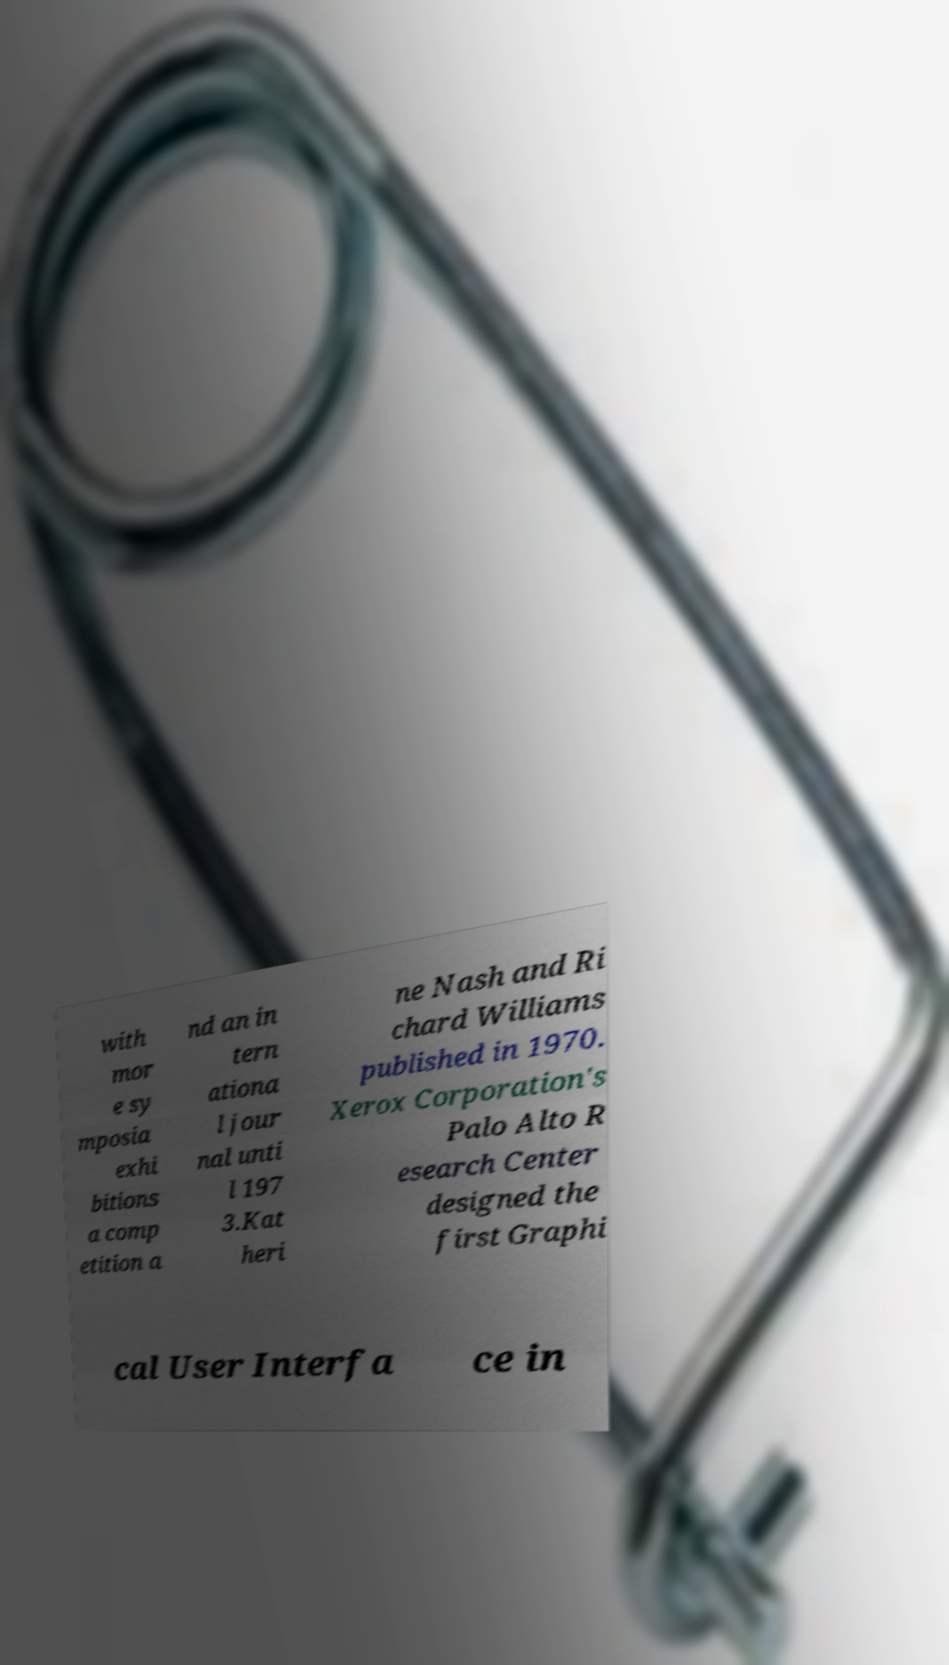Please identify and transcribe the text found in this image. with mor e sy mposia exhi bitions a comp etition a nd an in tern ationa l jour nal unti l 197 3.Kat heri ne Nash and Ri chard Williams published in 1970. Xerox Corporation's Palo Alto R esearch Center designed the first Graphi cal User Interfa ce in 